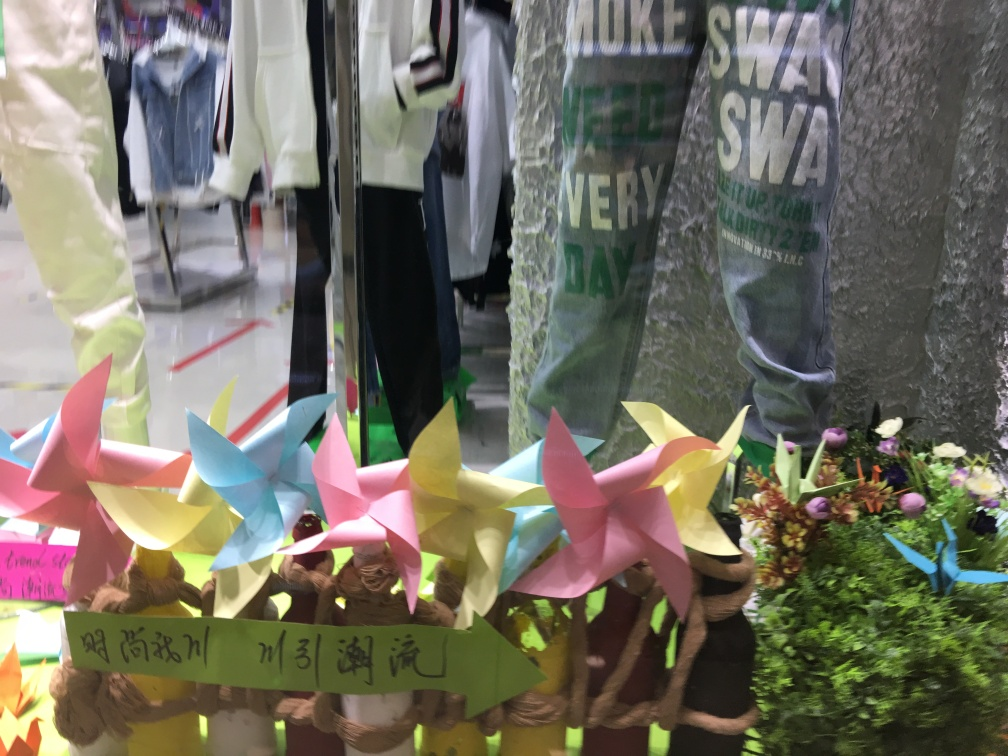What might be the significance of the Asian characters on the green strip in the image? The Asian characters on the green strip are likely a form of writing from a language such as Chinese or Japanese. If this is part of a display in a shop or an art installation, it could be conveying a message or a theme related to the items or the mood the creator wishes to express. Unfortunately, without a clearer view or context, it's difficult to provide a precise interpretation of their significance. 